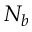Convert formula to latex. <formula><loc_0><loc_0><loc_500><loc_500>N _ { b }</formula> 